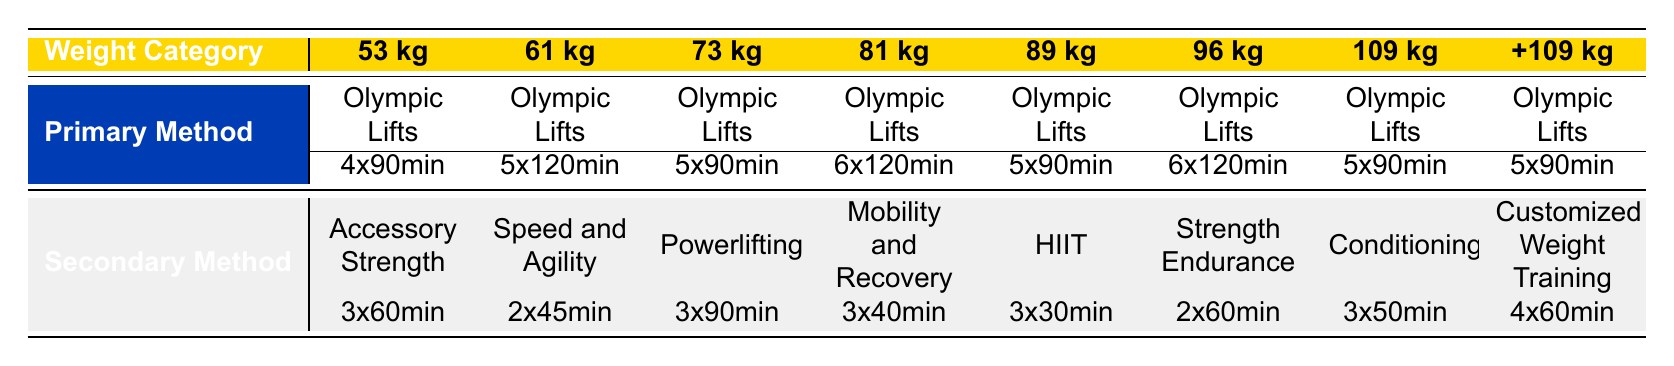What is the primary training method for the 81 kg weight category? The primary training method for the 81 kg weight category is Olympic Lifts, as indicated in the respective row of the table.
Answer: Olympic Lifts How many times per week do athletes in the 61 kg category perform Speed and Agility Drills? Athletes in the 61 kg weight category perform Speed and Agility Drills 2 times per week, as shown in the table under the secondary method for that category.
Answer: 2 What is the average duration in minutes for Olympic Lifts across all weight categories? The durations for Olympic Lifts are 90, 120, 90, 120, 90, 120, 90, and 90 minutes. Adding these gives 990 minutes, and dividing by 8 (the number of categories) gives an average of 123.75 minutes.
Answer: 123.75 Is High-Intensity Interval Training among the secondary methods for the 73 kg weight category? No, High-Intensity Interval Training (HIIT) is not listed as a secondary method for the 73 kg category; it is listed for the 89 kg category only.
Answer: No What is the total frequency per week for Olympic Lifts in the 96 kg and 109 kg categories? The frequency for Olympic Lifts in the 96 kg category is 6 times per week and for the 109 kg category is 5 times per week. Adding these together yields a total frequency of 11 times per week for both categories combined.
Answer: 11 